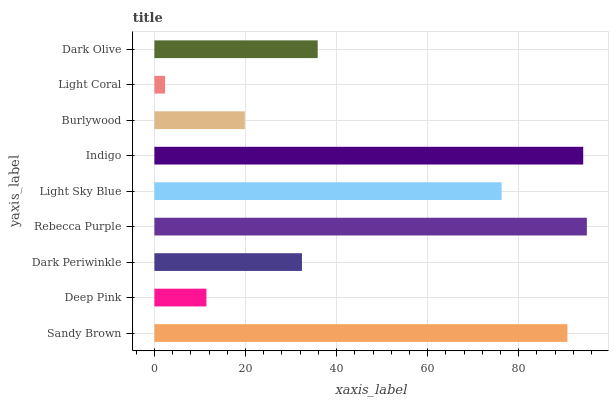Is Light Coral the minimum?
Answer yes or no. Yes. Is Rebecca Purple the maximum?
Answer yes or no. Yes. Is Deep Pink the minimum?
Answer yes or no. No. Is Deep Pink the maximum?
Answer yes or no. No. Is Sandy Brown greater than Deep Pink?
Answer yes or no. Yes. Is Deep Pink less than Sandy Brown?
Answer yes or no. Yes. Is Deep Pink greater than Sandy Brown?
Answer yes or no. No. Is Sandy Brown less than Deep Pink?
Answer yes or no. No. Is Dark Olive the high median?
Answer yes or no. Yes. Is Dark Olive the low median?
Answer yes or no. Yes. Is Burlywood the high median?
Answer yes or no. No. Is Dark Periwinkle the low median?
Answer yes or no. No. 